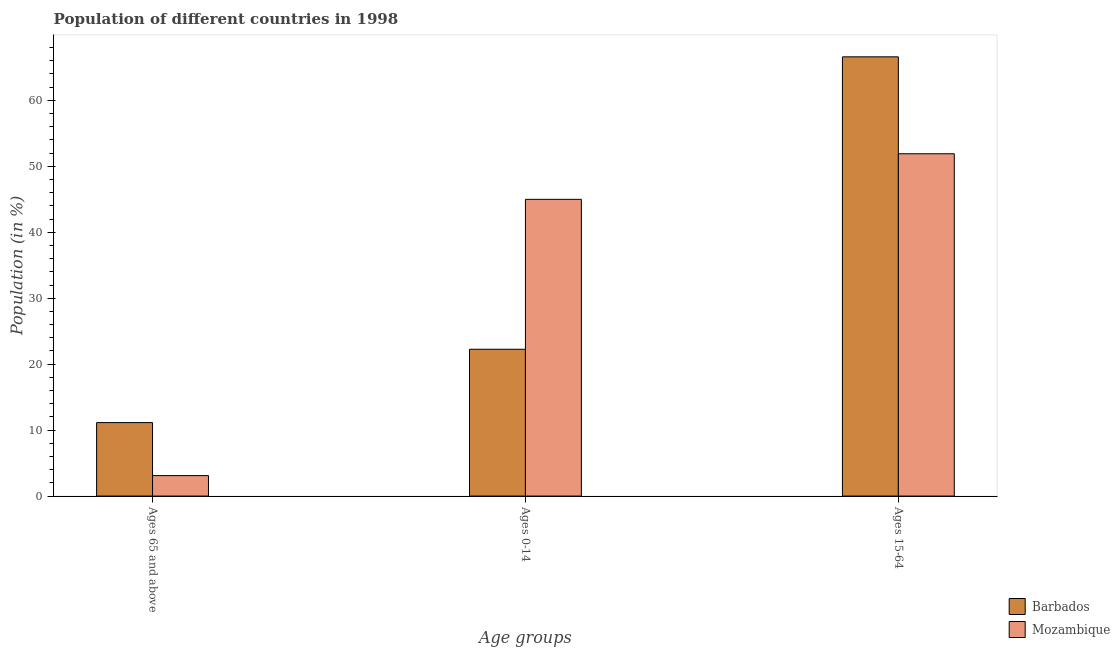How many different coloured bars are there?
Keep it short and to the point. 2. Are the number of bars per tick equal to the number of legend labels?
Ensure brevity in your answer.  Yes. Are the number of bars on each tick of the X-axis equal?
Your answer should be very brief. Yes. How many bars are there on the 1st tick from the left?
Keep it short and to the point. 2. How many bars are there on the 3rd tick from the right?
Provide a succinct answer. 2. What is the label of the 1st group of bars from the left?
Your response must be concise. Ages 65 and above. What is the percentage of population within the age-group 15-64 in Barbados?
Provide a short and direct response. 66.6. Across all countries, what is the maximum percentage of population within the age-group of 65 and above?
Your response must be concise. 11.14. Across all countries, what is the minimum percentage of population within the age-group of 65 and above?
Offer a very short reply. 3.1. In which country was the percentage of population within the age-group 15-64 maximum?
Your answer should be very brief. Barbados. In which country was the percentage of population within the age-group 15-64 minimum?
Give a very brief answer. Mozambique. What is the total percentage of population within the age-group 15-64 in the graph?
Your answer should be compact. 118.5. What is the difference between the percentage of population within the age-group 15-64 in Barbados and that in Mozambique?
Provide a short and direct response. 14.7. What is the difference between the percentage of population within the age-group of 65 and above in Mozambique and the percentage of population within the age-group 0-14 in Barbados?
Offer a terse response. -19.16. What is the average percentage of population within the age-group 0-14 per country?
Keep it short and to the point. 33.63. What is the difference between the percentage of population within the age-group 15-64 and percentage of population within the age-group 0-14 in Mozambique?
Offer a terse response. 6.91. What is the ratio of the percentage of population within the age-group of 65 and above in Mozambique to that in Barbados?
Your response must be concise. 0.28. What is the difference between the highest and the second highest percentage of population within the age-group 15-64?
Your answer should be very brief. 14.7. What is the difference between the highest and the lowest percentage of population within the age-group of 65 and above?
Keep it short and to the point. 8.04. What does the 2nd bar from the left in Ages 15-64 represents?
Your answer should be compact. Mozambique. What does the 2nd bar from the right in Ages 65 and above represents?
Provide a short and direct response. Barbados. How many bars are there?
Make the answer very short. 6. Are all the bars in the graph horizontal?
Make the answer very short. No. How many countries are there in the graph?
Keep it short and to the point. 2. What is the difference between two consecutive major ticks on the Y-axis?
Provide a short and direct response. 10. Are the values on the major ticks of Y-axis written in scientific E-notation?
Keep it short and to the point. No. Does the graph contain any zero values?
Offer a terse response. No. Does the graph contain grids?
Your response must be concise. No. What is the title of the graph?
Ensure brevity in your answer.  Population of different countries in 1998. What is the label or title of the X-axis?
Provide a short and direct response. Age groups. What is the label or title of the Y-axis?
Offer a very short reply. Population (in %). What is the Population (in %) of Barbados in Ages 65 and above?
Ensure brevity in your answer.  11.14. What is the Population (in %) in Mozambique in Ages 65 and above?
Offer a very short reply. 3.1. What is the Population (in %) of Barbados in Ages 0-14?
Your answer should be very brief. 22.26. What is the Population (in %) of Mozambique in Ages 0-14?
Offer a terse response. 44.99. What is the Population (in %) in Barbados in Ages 15-64?
Your answer should be compact. 66.6. What is the Population (in %) of Mozambique in Ages 15-64?
Ensure brevity in your answer.  51.9. Across all Age groups, what is the maximum Population (in %) of Barbados?
Keep it short and to the point. 66.6. Across all Age groups, what is the maximum Population (in %) of Mozambique?
Make the answer very short. 51.9. Across all Age groups, what is the minimum Population (in %) of Barbados?
Offer a terse response. 11.14. Across all Age groups, what is the minimum Population (in %) in Mozambique?
Provide a short and direct response. 3.1. What is the total Population (in %) of Barbados in the graph?
Provide a short and direct response. 100. What is the total Population (in %) of Mozambique in the graph?
Keep it short and to the point. 100. What is the difference between the Population (in %) in Barbados in Ages 65 and above and that in Ages 0-14?
Give a very brief answer. -11.12. What is the difference between the Population (in %) of Mozambique in Ages 65 and above and that in Ages 0-14?
Offer a terse response. -41.89. What is the difference between the Population (in %) in Barbados in Ages 65 and above and that in Ages 15-64?
Offer a terse response. -55.46. What is the difference between the Population (in %) in Mozambique in Ages 65 and above and that in Ages 15-64?
Your answer should be compact. -48.8. What is the difference between the Population (in %) in Barbados in Ages 0-14 and that in Ages 15-64?
Offer a very short reply. -44.34. What is the difference between the Population (in %) in Mozambique in Ages 0-14 and that in Ages 15-64?
Your answer should be compact. -6.91. What is the difference between the Population (in %) of Barbados in Ages 65 and above and the Population (in %) of Mozambique in Ages 0-14?
Make the answer very short. -33.85. What is the difference between the Population (in %) of Barbados in Ages 65 and above and the Population (in %) of Mozambique in Ages 15-64?
Your answer should be compact. -40.76. What is the difference between the Population (in %) in Barbados in Ages 0-14 and the Population (in %) in Mozambique in Ages 15-64?
Ensure brevity in your answer.  -29.64. What is the average Population (in %) of Barbados per Age groups?
Keep it short and to the point. 33.33. What is the average Population (in %) of Mozambique per Age groups?
Keep it short and to the point. 33.33. What is the difference between the Population (in %) in Barbados and Population (in %) in Mozambique in Ages 65 and above?
Ensure brevity in your answer.  8.04. What is the difference between the Population (in %) of Barbados and Population (in %) of Mozambique in Ages 0-14?
Provide a succinct answer. -22.73. What is the difference between the Population (in %) of Barbados and Population (in %) of Mozambique in Ages 15-64?
Offer a very short reply. 14.7. What is the ratio of the Population (in %) of Barbados in Ages 65 and above to that in Ages 0-14?
Keep it short and to the point. 0.5. What is the ratio of the Population (in %) in Mozambique in Ages 65 and above to that in Ages 0-14?
Give a very brief answer. 0.07. What is the ratio of the Population (in %) in Barbados in Ages 65 and above to that in Ages 15-64?
Make the answer very short. 0.17. What is the ratio of the Population (in %) of Mozambique in Ages 65 and above to that in Ages 15-64?
Ensure brevity in your answer.  0.06. What is the ratio of the Population (in %) of Barbados in Ages 0-14 to that in Ages 15-64?
Make the answer very short. 0.33. What is the ratio of the Population (in %) in Mozambique in Ages 0-14 to that in Ages 15-64?
Make the answer very short. 0.87. What is the difference between the highest and the second highest Population (in %) in Barbados?
Your answer should be compact. 44.34. What is the difference between the highest and the second highest Population (in %) in Mozambique?
Offer a terse response. 6.91. What is the difference between the highest and the lowest Population (in %) of Barbados?
Ensure brevity in your answer.  55.46. What is the difference between the highest and the lowest Population (in %) of Mozambique?
Your answer should be compact. 48.8. 